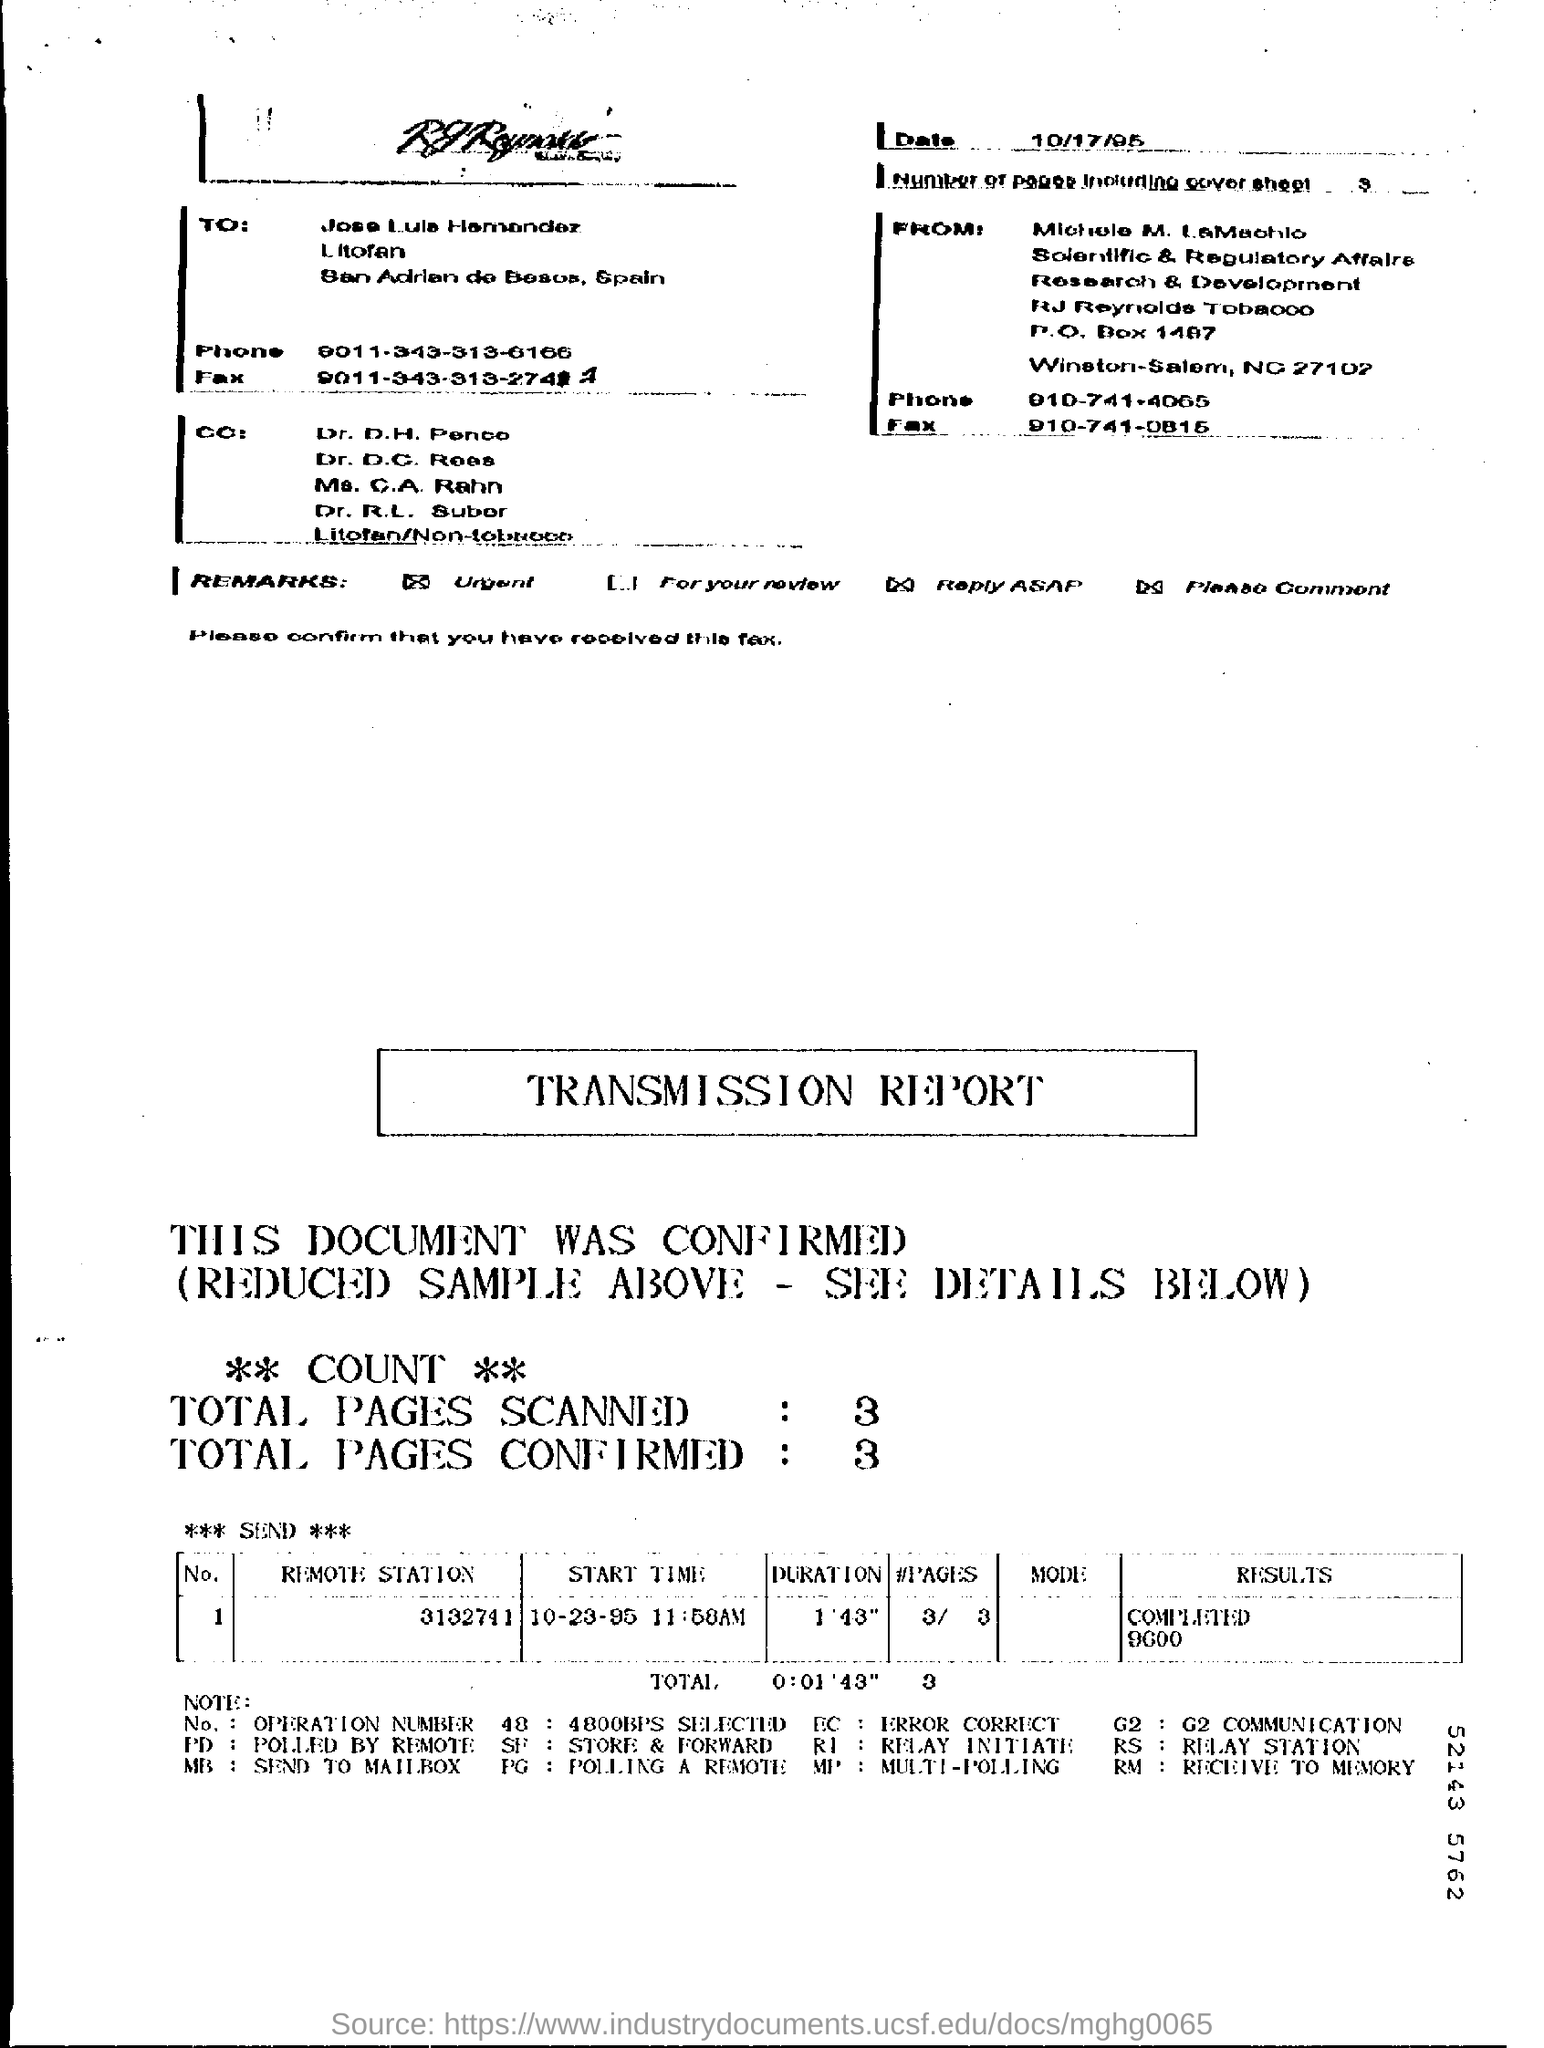Point out several critical features in this image. The duration for Remote station 3132741 is 1 minute and 43 seconds. I would like to know the fax number for Jose Louis Hamandez, which is 9011-343-313-2741. The date is October 17, 1995. The result for Remote station 3132741 has been completed. The phone number for Michelle M. LaMachlo is 910-741-4065. 